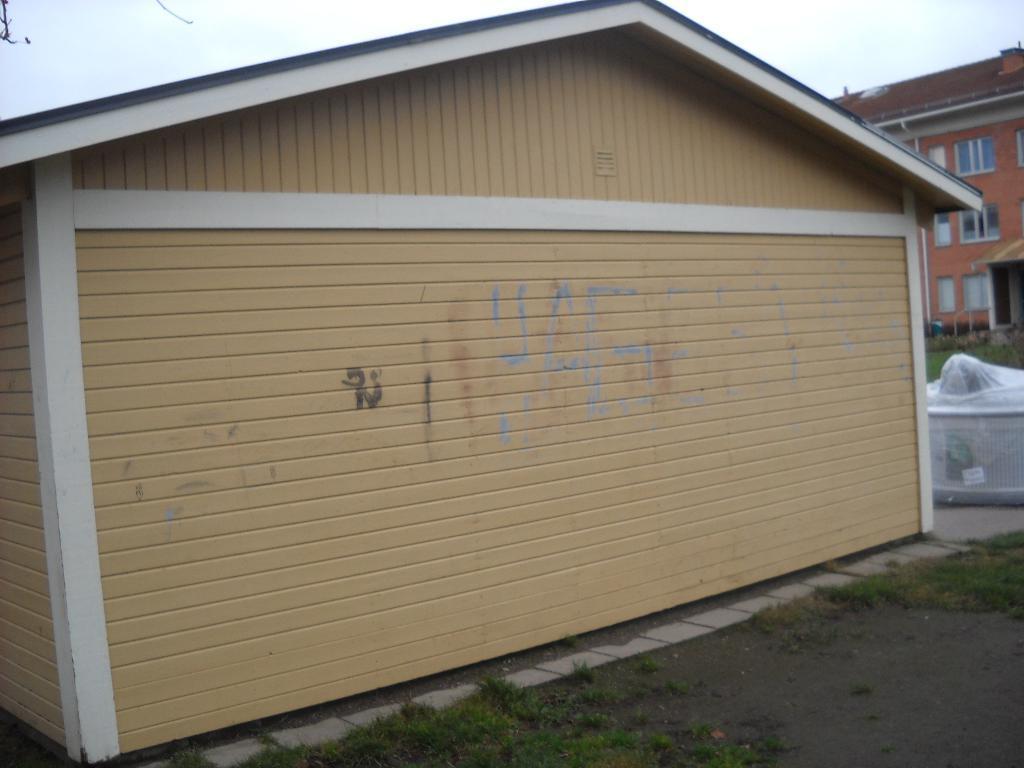Could you give a brief overview of what you see in this image? In this image there is the sky towards the top of the image, there is a building towards the right of the image, there is a building towards the left of the image, there are windows, there is a wall, there is an object towards the right of the image, there is road towards the right of the image, there is grass on the road, there is an object towards the top of the image. 